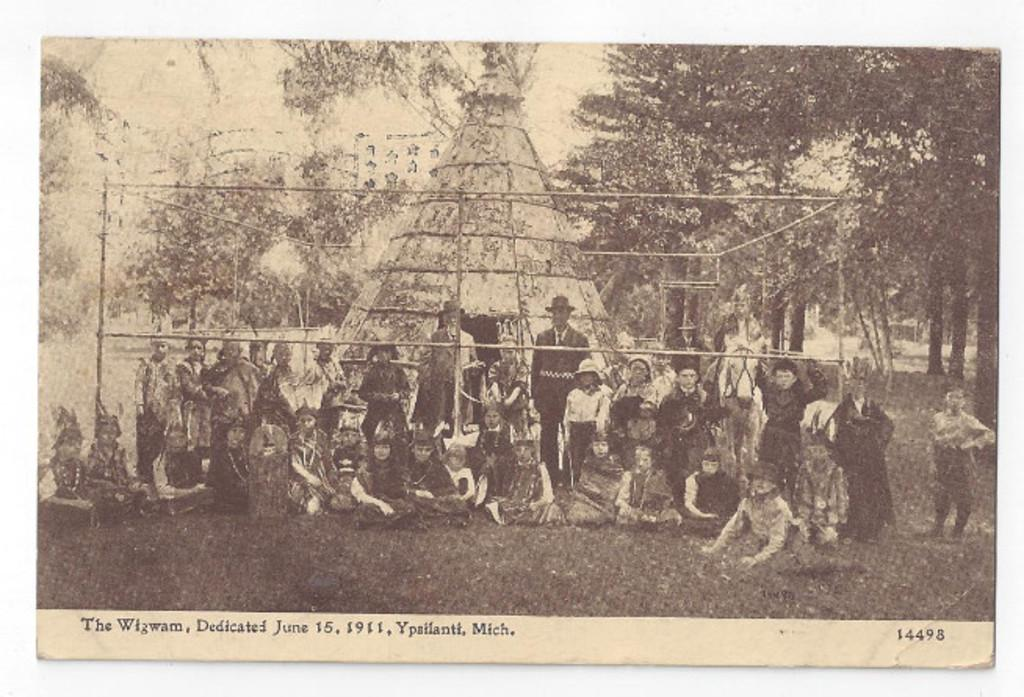What is the main subject of the image? The main subject of the image is a photograph. Can you describe the people in the image? There are people in the center of the image. What can be seen in the background of the photograph? There are trees in the background of the image. What type of trousers are the people wearing in the image? There is no information about the type of trousers the people are wearing in the image. What is the condition of the field in the image? There is no field present in the image; it features a photograph with people and trees in the background. 